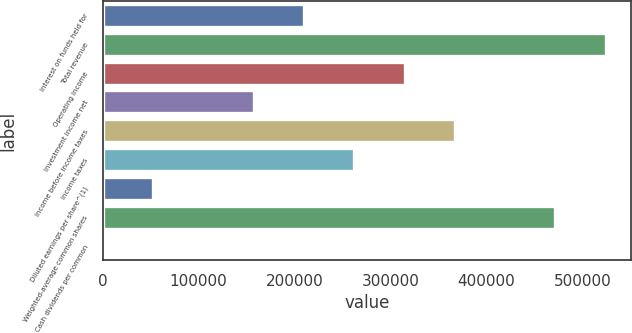Convert chart. <chart><loc_0><loc_0><loc_500><loc_500><bar_chart><fcel>Interest on funds held for<fcel>Total revenue<fcel>Operating income<fcel>Investment income net<fcel>Income before income taxes<fcel>Income taxes<fcel>Diluted earnings per share^(1)<fcel>Weighted-average common shares<fcel>Cash dividends per common<nl><fcel>209664<fcel>524160<fcel>314496<fcel>157248<fcel>366912<fcel>262080<fcel>52416.3<fcel>471744<fcel>0.31<nl></chart> 